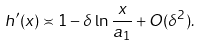<formula> <loc_0><loc_0><loc_500><loc_500>h ^ { \prime } ( x ) \asymp 1 - \delta \, \ln \frac { x } { a _ { 1 } } + O ( \delta ^ { 2 } ) .</formula> 